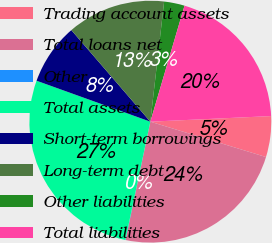<chart> <loc_0><loc_0><loc_500><loc_500><pie_chart><fcel>Trading account assets<fcel>Total loans net<fcel>Other<fcel>Total assets<fcel>Short-term borrowings<fcel>Long-term debt<fcel>Other liabilities<fcel>Total liabilities<nl><fcel>5.46%<fcel>23.56%<fcel>0.03%<fcel>27.18%<fcel>8.17%<fcel>13.15%<fcel>2.74%<fcel>19.7%<nl></chart> 